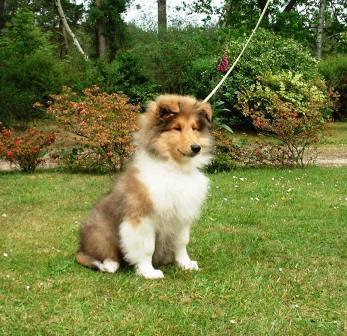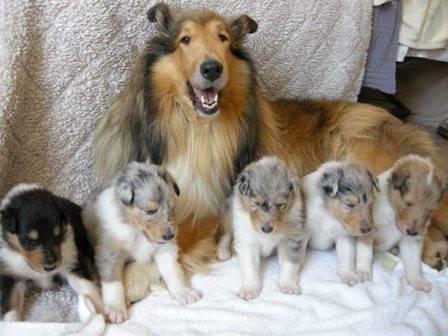The first image is the image on the left, the second image is the image on the right. Evaluate the accuracy of this statement regarding the images: "There is dog on top of grass in one of the images.". Is it true? Answer yes or no. Yes. The first image is the image on the left, the second image is the image on the right. Given the left and right images, does the statement "there are two dogs in the image pair" hold true? Answer yes or no. No. 